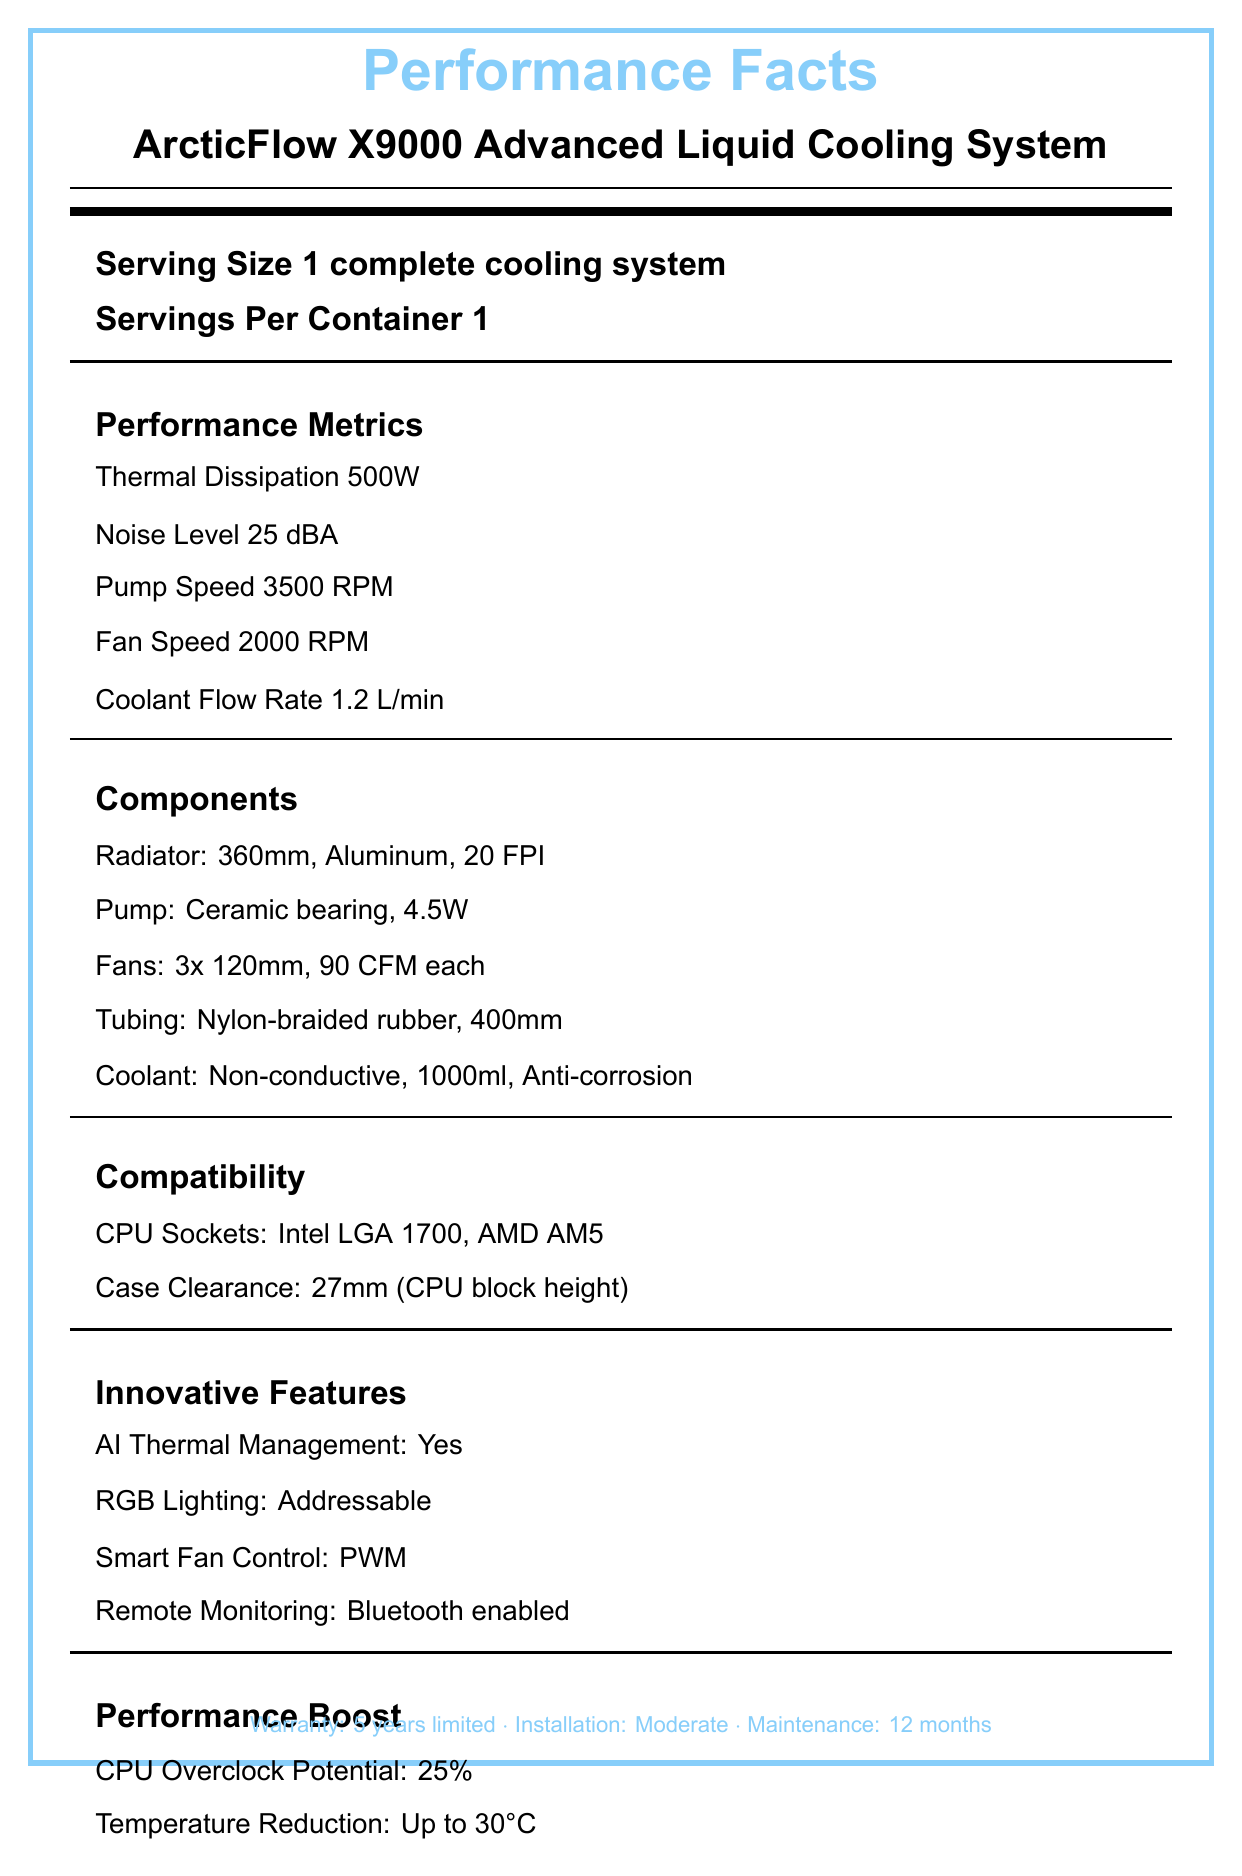what is the noise level of the cooling system? The document lists the noise level under the "Performance Metrics" section.
Answer: 25 dBA how many fans does the ArcticFlow X9000 have? The "Components" section specifies that there are 3 fans, each 120mm in size.
Answer: 3 what type of coolant is used? The "Components" section mentions the coolant type as "Non-conductive" under the "Coolant" sub-item.
Answer: Non-conductive what are the compatible CPU sockets for this cooling system? The "Compatibility" section lists "CPU Sockets" that include "Intel LGA 1700" and "AMD AM5".
Answer: Intel LGA 1700, AMD AM5 how is the tubing described in the ArcticFlow X9000? The "Components" section describes the tubing material and length under the "Tubing" sub-item.
Answer: Nylon-braided rubber, 400mm what are the innovative features included in this cooling system? A. AI Thermal Management B. RGB Lighting C. Smart Fan Control D. All of the above The "Innovative Features" section lists AI Thermal Management, RGB Lighting, and Smart Fan Control among others.
Answer: D what is the radiator size and material in the ArcticFlow X9000? A. 240mm, Copper B. 360mm, Aluminum C. 280mm, Aluminum D. 360mm, Copper The "Components" section indicates the radiator is 360mm in size and made of aluminum.
Answer: B can the ArcticFlow X9000 be monitored remotely? The "Innovative Features" section lists "Remote Monitoring: Bluetooth enabled," which allows for remote monitoring.
Answer: Yes do the materials used in the ArcticFlow X9000 have a high recyclability percentage? The "Environmental Impact" section mentions that 85% of the materials are recyclable.
Answer: Yes summarize the main performance advantages of using the ArcticFlow X9000. The document highlights the multiple performance benefits of the ArcticFlow X9000, focusing on its thermal management, efficiency, and compatibility features.
Answer: The ArcticFlow X9000, an advanced liquid cooling system, offers significant performance boosts with a thermal dissipation of 500W and noise level of 25 dBA. It features innovative components such as a 360mm aluminum radiator, non-conductive coolant, and AI thermal management. The system supports a variety of CPU sockets and includes smart fan control, remote monitoring, and RGB lighting, making it a high-performance and efficient cooling solution. how does the ArcticFlow X9000 impact CPU overclock potential? The "Performance Boost" section states that there is a 25% potential increase in CPU overclocking when using the ArcticFlow X9000.
Answer: 25% increase what is the power consumption of the pump? The "Components" section under the "Pump" sub-item lists the power consumption as 4.5W.
Answer: 4.5W what is the maximum temperature reduction achieved by the ArcticFlow X9000? The "Performance Boost" section mentions a temperature reduction of up to 30°C.
Answer: Up to 30°C is the coolant volume of the ArcticFlow X9000 more than 1 liter? The "Components" section lists the coolant volume as 1000ml, which is exactly 1 liter, so the answer can be contextually considered as "Yes" for most practical purposes.
Answer: Yes what is the length of the warranty for the ArcticFlow X9000? The document mentions a 5 years limited warranty at the bottom.
Answer: 5 years what is the energy efficiency rating of the ArcticFlow X9000? The "Environmental Impact" section specifies an energy efficiency rating of A+.
Answer: A+ is the installation difficulty of the ArcticFlow X9000 considered easy? The document mentions the installation difficulty as "Moderate."
Answer: No what is the amperage required for the ArcticFlow X9000? The "Power Requirements" section lists the amperage as 2A.
Answer: 2A what is the percentage of recyclable materials used in the ArcticFlow X9000? The "Environmental Impact" section states that the system is made of 85% recyclable materials.
Answer: 85% what is the warranty period for the fans used in the cooling system? The document only provides the overall warranty period for the cooling system as a whole but does not specify individual components.
Answer: Not enough information how frequently should maintenance be performed on the ArcticFlow X9000? The document states that the maintenance interval is 12 months.
Answer: 12 months 